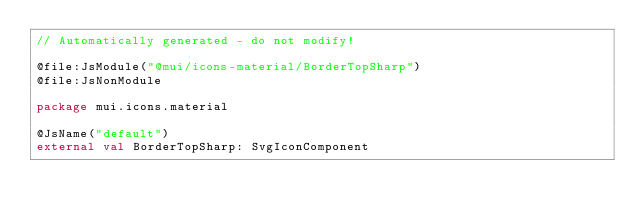Convert code to text. <code><loc_0><loc_0><loc_500><loc_500><_Kotlin_>// Automatically generated - do not modify!

@file:JsModule("@mui/icons-material/BorderTopSharp")
@file:JsNonModule

package mui.icons.material

@JsName("default")
external val BorderTopSharp: SvgIconComponent
</code> 